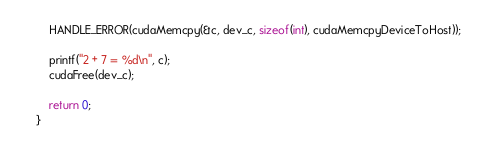Convert code to text. <code><loc_0><loc_0><loc_500><loc_500><_Cuda_>
    HANDLE_ERROR(cudaMemcpy(&c, dev_c, sizeof(int), cudaMemcpyDeviceToHost));

    printf("2 + 7 = %d\n", c);
    cudaFree(dev_c);

    return 0;
}</code> 